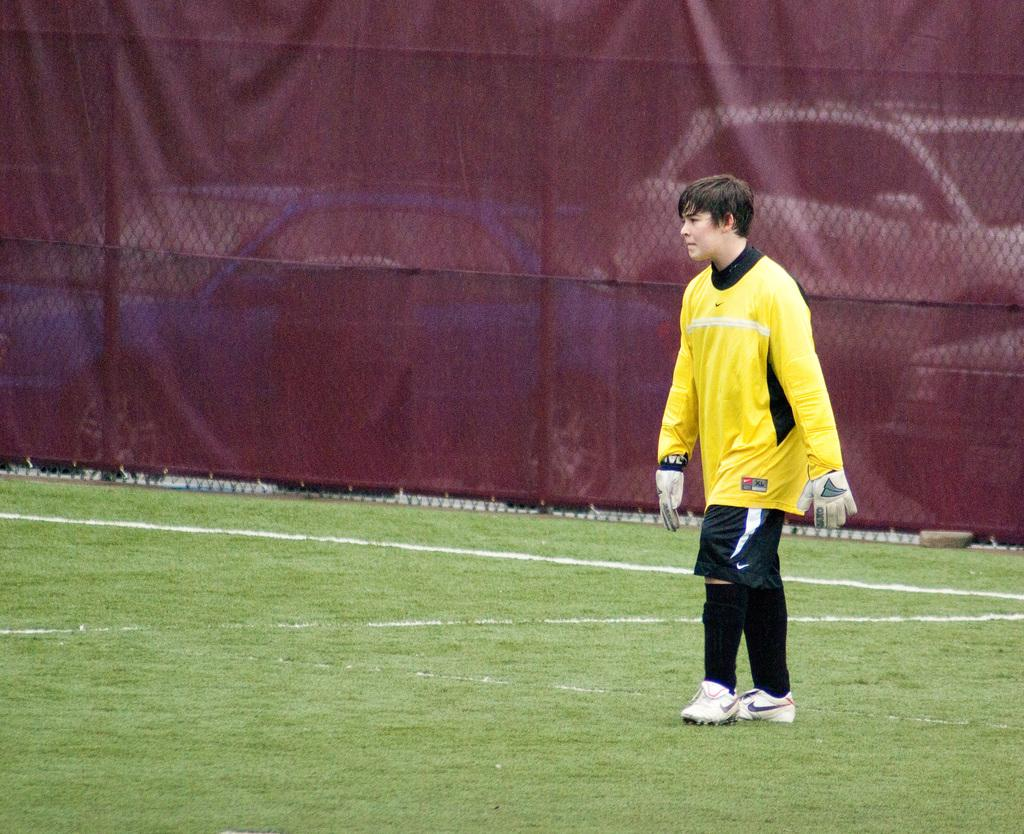Where is the boy located in the image? The boy is on the right side of the image. What is the boy standing on? The boy is on the grassland. What can be seen in the background of the image? There is a net, a curtain, and cars in the background of the image. What type of vegetation is visible behind the cars? It appears that there are trees behind the cars. What type of egg is the boy holding in the image? There is no egg present in the image; the boy is not holding anything. What type of wine is being served at the event in the image? There is no event or wine present in the image; it features a boy standing on grassland with various background elements. 